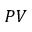<formula> <loc_0><loc_0><loc_500><loc_500>P V</formula> 